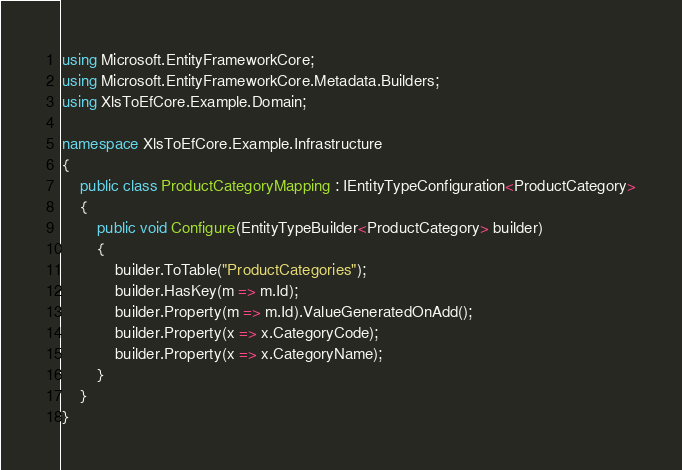<code> <loc_0><loc_0><loc_500><loc_500><_C#_>using Microsoft.EntityFrameworkCore;
using Microsoft.EntityFrameworkCore.Metadata.Builders;
using XlsToEfCore.Example.Domain;

namespace XlsToEfCore.Example.Infrastructure
{
    public class ProductCategoryMapping : IEntityTypeConfiguration<ProductCategory>
    {
        public void Configure(EntityTypeBuilder<ProductCategory> builder)
        {
            builder.ToTable("ProductCategories");
            builder.HasKey(m => m.Id);
            builder.Property(m => m.Id).ValueGeneratedOnAdd();
            builder.Property(x => x.CategoryCode);
            builder.Property(x => x.CategoryName);
        }
    }
}</code> 